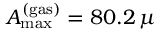<formula> <loc_0><loc_0><loc_500><loc_500>A _ { \max } ^ { ( g a s ) } = 8 0 . 2 \, \mu</formula> 